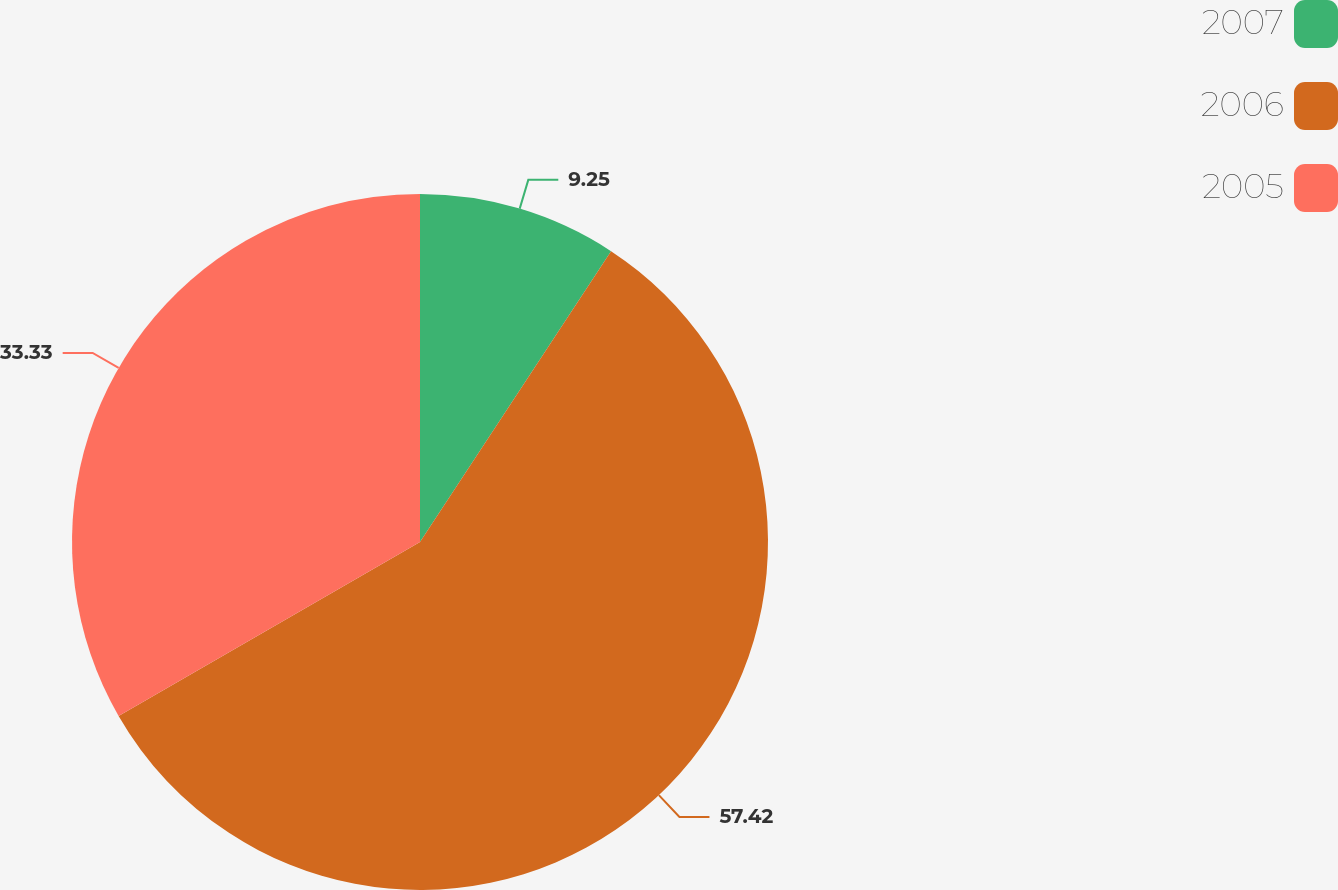<chart> <loc_0><loc_0><loc_500><loc_500><pie_chart><fcel>2007<fcel>2006<fcel>2005<nl><fcel>9.25%<fcel>57.42%<fcel>33.33%<nl></chart> 